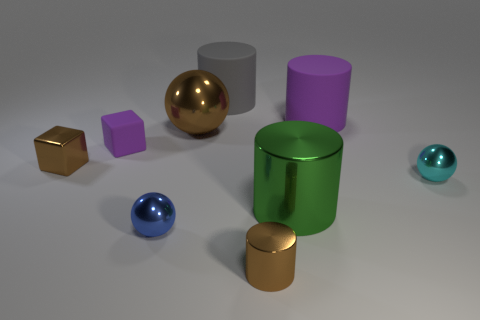Is there anything else that has the same shape as the tiny blue metal object?
Make the answer very short. Yes. There is a large sphere that is the same material as the big green cylinder; what is its color?
Give a very brief answer. Brown. There is a purple thing that is on the right side of the purple object that is on the left side of the gray rubber thing; are there any cyan things in front of it?
Your response must be concise. Yes. Is the number of big gray rubber things that are on the right side of the big gray matte cylinder less than the number of large shiny objects in front of the tiny blue object?
Offer a terse response. No. What number of large purple objects have the same material as the tiny cyan object?
Provide a short and direct response. 0. There is a brown cylinder; is its size the same as the metal sphere to the right of the large green metal thing?
Your response must be concise. Yes. There is a cube that is the same color as the tiny shiny cylinder; what is it made of?
Provide a succinct answer. Metal. There is a shiny object that is right of the matte thing right of the object behind the large purple matte cylinder; how big is it?
Your answer should be compact. Small. Is the number of big green cylinders that are in front of the large green cylinder greater than the number of blocks on the right side of the small blue shiny object?
Your response must be concise. No. There is a large metallic thing that is to the left of the big gray cylinder; how many big objects are behind it?
Give a very brief answer. 2. 